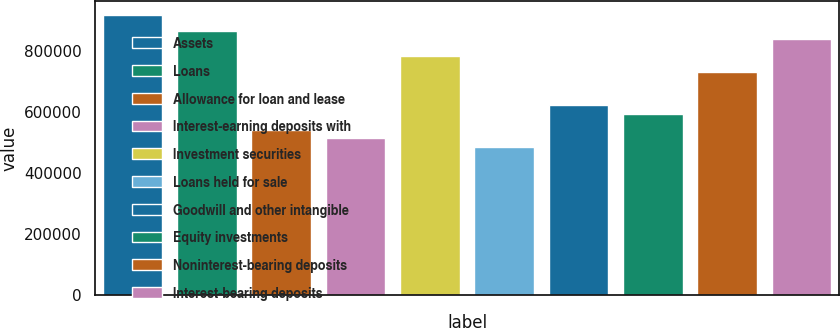<chart> <loc_0><loc_0><loc_500><loc_500><bar_chart><fcel>Assets<fcel>Loans<fcel>Allowance for loan and lease<fcel>Interest-earning deposits with<fcel>Investment securities<fcel>Loans held for sale<fcel>Goodwill and other intangible<fcel>Equity investments<fcel>Noninterest-bearing deposits<fcel>Interest-bearing deposits<nl><fcel>917532<fcel>863560<fcel>539725<fcel>512739<fcel>782601<fcel>485753<fcel>620684<fcel>593697<fcel>728629<fcel>836573<nl></chart> 